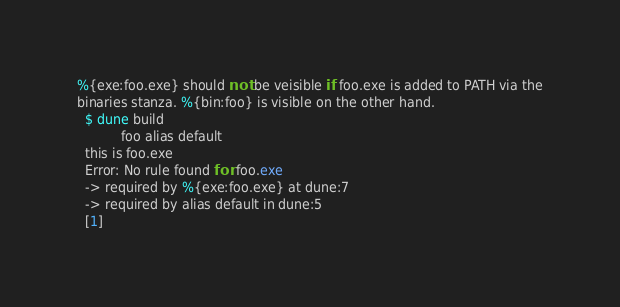<code> <loc_0><loc_0><loc_500><loc_500><_Perl_>%{exe:foo.exe} should not be veisible if foo.exe is added to PATH via the
binaries stanza. %{bin:foo} is visible on the other hand.
  $ dune build
           foo alias default
  this is foo.exe
  Error: No rule found for foo.exe
  -> required by %{exe:foo.exe} at dune:7
  -> required by alias default in dune:5
  [1]
</code> 